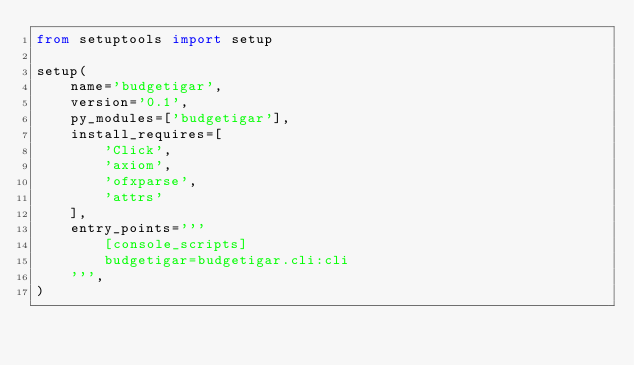<code> <loc_0><loc_0><loc_500><loc_500><_Python_>from setuptools import setup

setup(
    name='budgetigar',
    version='0.1',
    py_modules=['budgetigar'],
    install_requires=[
        'Click',
        'axiom',
        'ofxparse',
        'attrs'
    ],
    entry_points='''
        [console_scripts]
        budgetigar=budgetigar.cli:cli
    ''',
)
</code> 